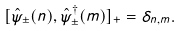<formula> <loc_0><loc_0><loc_500><loc_500>[ \hat { \psi } _ { \pm } ( n ) , \hat { \psi } _ { \pm } ^ { \dagger } ( m ) ] _ { + } = \delta _ { n , m } .</formula> 